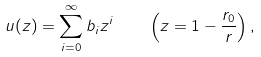<formula> <loc_0><loc_0><loc_500><loc_500>u ( z ) = \sum _ { i = 0 } ^ { \infty } b _ { i } z ^ { i } \, \quad \left ( z = 1 - \frac { r _ { 0 } } { r } \right ) ,</formula> 